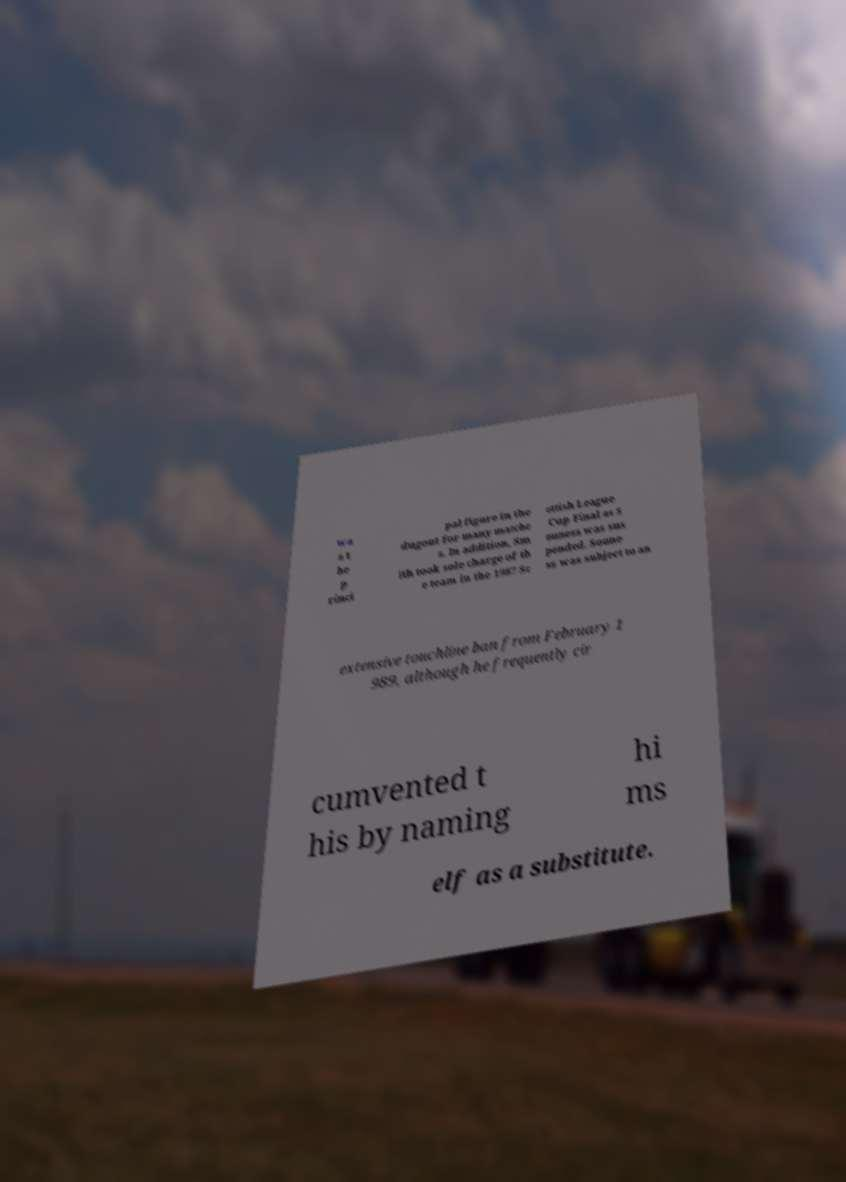Please identify and transcribe the text found in this image. wa s t he p rinci pal figure in the dugout for many matche s. In addition, Sm ith took sole charge of th e team in the 1987 Sc ottish League Cup Final as S ouness was sus pended. Soune ss was subject to an extensive touchline ban from February 1 989, although he frequently cir cumvented t his by naming hi ms elf as a substitute. 